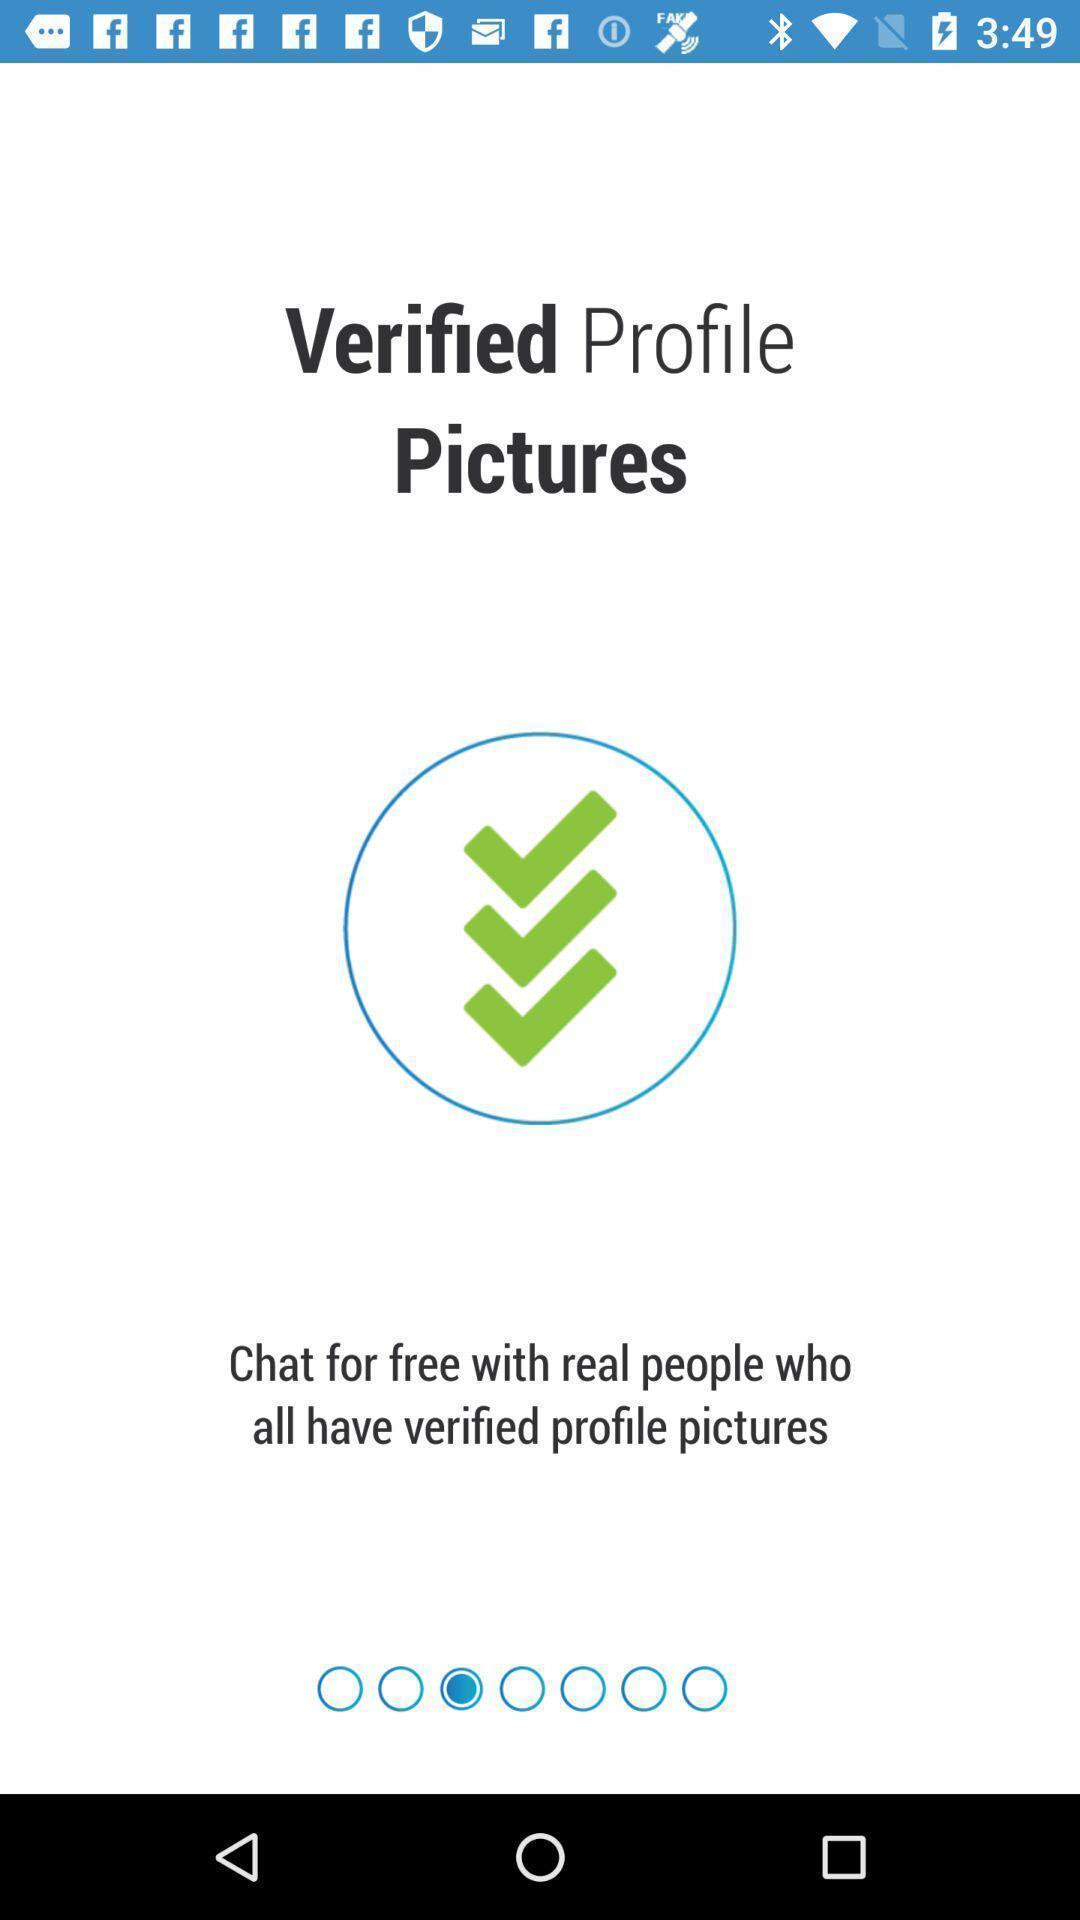Provide a textual representation of this image. Page showing welcomes slides for app. 